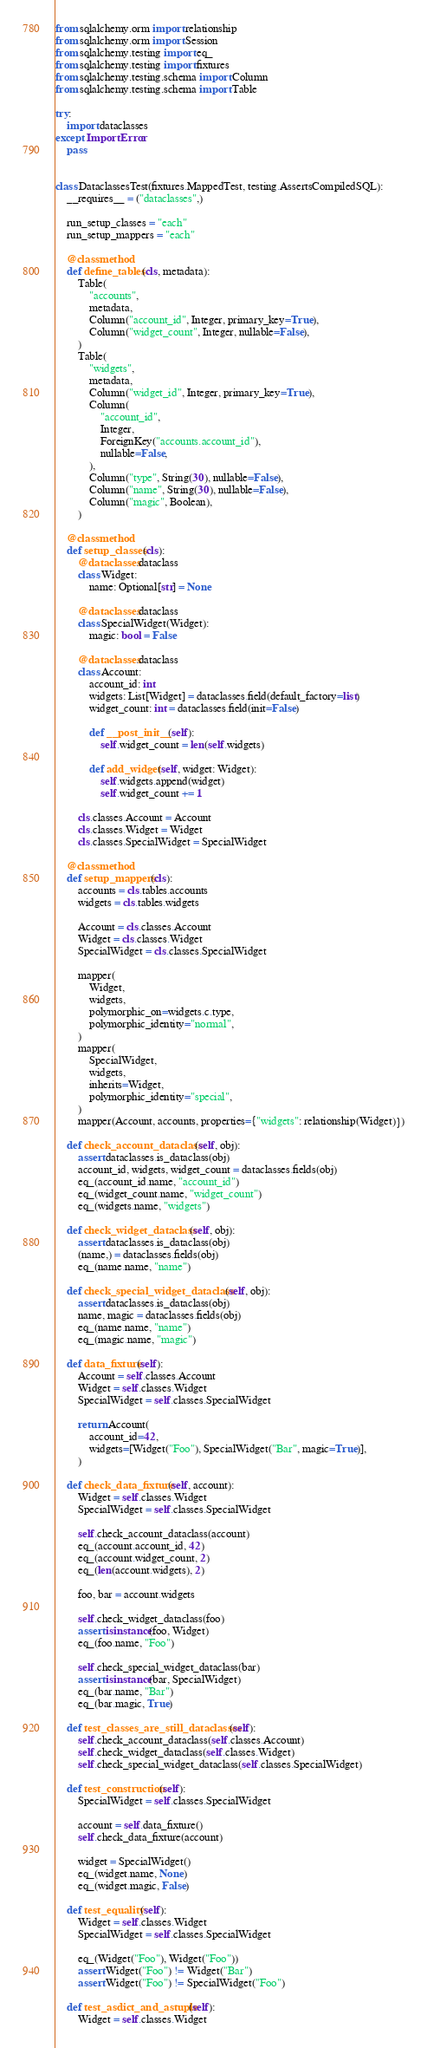<code> <loc_0><loc_0><loc_500><loc_500><_Python_>from sqlalchemy.orm import relationship
from sqlalchemy.orm import Session
from sqlalchemy.testing import eq_
from sqlalchemy.testing import fixtures
from sqlalchemy.testing.schema import Column
from sqlalchemy.testing.schema import Table

try:
    import dataclasses
except ImportError:
    pass


class DataclassesTest(fixtures.MappedTest, testing.AssertsCompiledSQL):
    __requires__ = ("dataclasses",)

    run_setup_classes = "each"
    run_setup_mappers = "each"

    @classmethod
    def define_tables(cls, metadata):
        Table(
            "accounts",
            metadata,
            Column("account_id", Integer, primary_key=True),
            Column("widget_count", Integer, nullable=False),
        )
        Table(
            "widgets",
            metadata,
            Column("widget_id", Integer, primary_key=True),
            Column(
                "account_id",
                Integer,
                ForeignKey("accounts.account_id"),
                nullable=False,
            ),
            Column("type", String(30), nullable=False),
            Column("name", String(30), nullable=False),
            Column("magic", Boolean),
        )

    @classmethod
    def setup_classes(cls):
        @dataclasses.dataclass
        class Widget:
            name: Optional[str] = None

        @dataclasses.dataclass
        class SpecialWidget(Widget):
            magic: bool = False

        @dataclasses.dataclass
        class Account:
            account_id: int
            widgets: List[Widget] = dataclasses.field(default_factory=list)
            widget_count: int = dataclasses.field(init=False)

            def __post_init__(self):
                self.widget_count = len(self.widgets)

            def add_widget(self, widget: Widget):
                self.widgets.append(widget)
                self.widget_count += 1

        cls.classes.Account = Account
        cls.classes.Widget = Widget
        cls.classes.SpecialWidget = SpecialWidget

    @classmethod
    def setup_mappers(cls):
        accounts = cls.tables.accounts
        widgets = cls.tables.widgets

        Account = cls.classes.Account
        Widget = cls.classes.Widget
        SpecialWidget = cls.classes.SpecialWidget

        mapper(
            Widget,
            widgets,
            polymorphic_on=widgets.c.type,
            polymorphic_identity="normal",
        )
        mapper(
            SpecialWidget,
            widgets,
            inherits=Widget,
            polymorphic_identity="special",
        )
        mapper(Account, accounts, properties={"widgets": relationship(Widget)})

    def check_account_dataclass(self, obj):
        assert dataclasses.is_dataclass(obj)
        account_id, widgets, widget_count = dataclasses.fields(obj)
        eq_(account_id.name, "account_id")
        eq_(widget_count.name, "widget_count")
        eq_(widgets.name, "widgets")

    def check_widget_dataclass(self, obj):
        assert dataclasses.is_dataclass(obj)
        (name,) = dataclasses.fields(obj)
        eq_(name.name, "name")

    def check_special_widget_dataclass(self, obj):
        assert dataclasses.is_dataclass(obj)
        name, magic = dataclasses.fields(obj)
        eq_(name.name, "name")
        eq_(magic.name, "magic")

    def data_fixture(self):
        Account = self.classes.Account
        Widget = self.classes.Widget
        SpecialWidget = self.classes.SpecialWidget

        return Account(
            account_id=42,
            widgets=[Widget("Foo"), SpecialWidget("Bar", magic=True)],
        )

    def check_data_fixture(self, account):
        Widget = self.classes.Widget
        SpecialWidget = self.classes.SpecialWidget

        self.check_account_dataclass(account)
        eq_(account.account_id, 42)
        eq_(account.widget_count, 2)
        eq_(len(account.widgets), 2)

        foo, bar = account.widgets

        self.check_widget_dataclass(foo)
        assert isinstance(foo, Widget)
        eq_(foo.name, "Foo")

        self.check_special_widget_dataclass(bar)
        assert isinstance(bar, SpecialWidget)
        eq_(bar.name, "Bar")
        eq_(bar.magic, True)

    def test_classes_are_still_dataclasses(self):
        self.check_account_dataclass(self.classes.Account)
        self.check_widget_dataclass(self.classes.Widget)
        self.check_special_widget_dataclass(self.classes.SpecialWidget)

    def test_construction(self):
        SpecialWidget = self.classes.SpecialWidget

        account = self.data_fixture()
        self.check_data_fixture(account)

        widget = SpecialWidget()
        eq_(widget.name, None)
        eq_(widget.magic, False)

    def test_equality(self):
        Widget = self.classes.Widget
        SpecialWidget = self.classes.SpecialWidget

        eq_(Widget("Foo"), Widget("Foo"))
        assert Widget("Foo") != Widget("Bar")
        assert Widget("Foo") != SpecialWidget("Foo")

    def test_asdict_and_astuple(self):
        Widget = self.classes.Widget</code> 